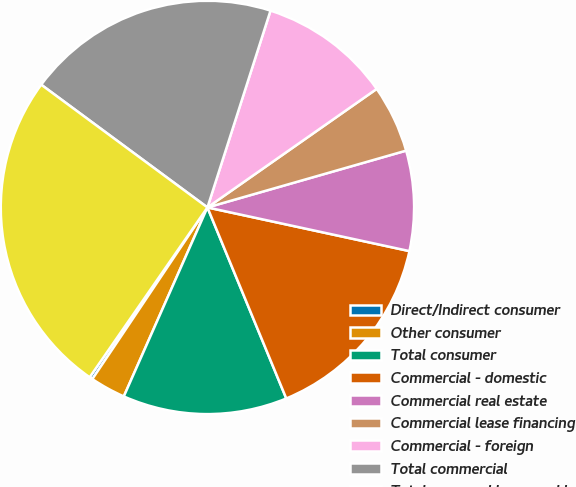<chart> <loc_0><loc_0><loc_500><loc_500><pie_chart><fcel>Direct/Indirect consumer<fcel>Other consumer<fcel>Total consumer<fcel>Commercial - domestic<fcel>Commercial real estate<fcel>Commercial lease financing<fcel>Commercial - foreign<fcel>Total commercial<fcel>Total managed loans and leases<nl><fcel>0.25%<fcel>2.77%<fcel>12.86%<fcel>15.38%<fcel>7.82%<fcel>5.29%<fcel>10.34%<fcel>19.81%<fcel>25.47%<nl></chart> 